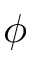<formula> <loc_0><loc_0><loc_500><loc_500>\phi</formula> 